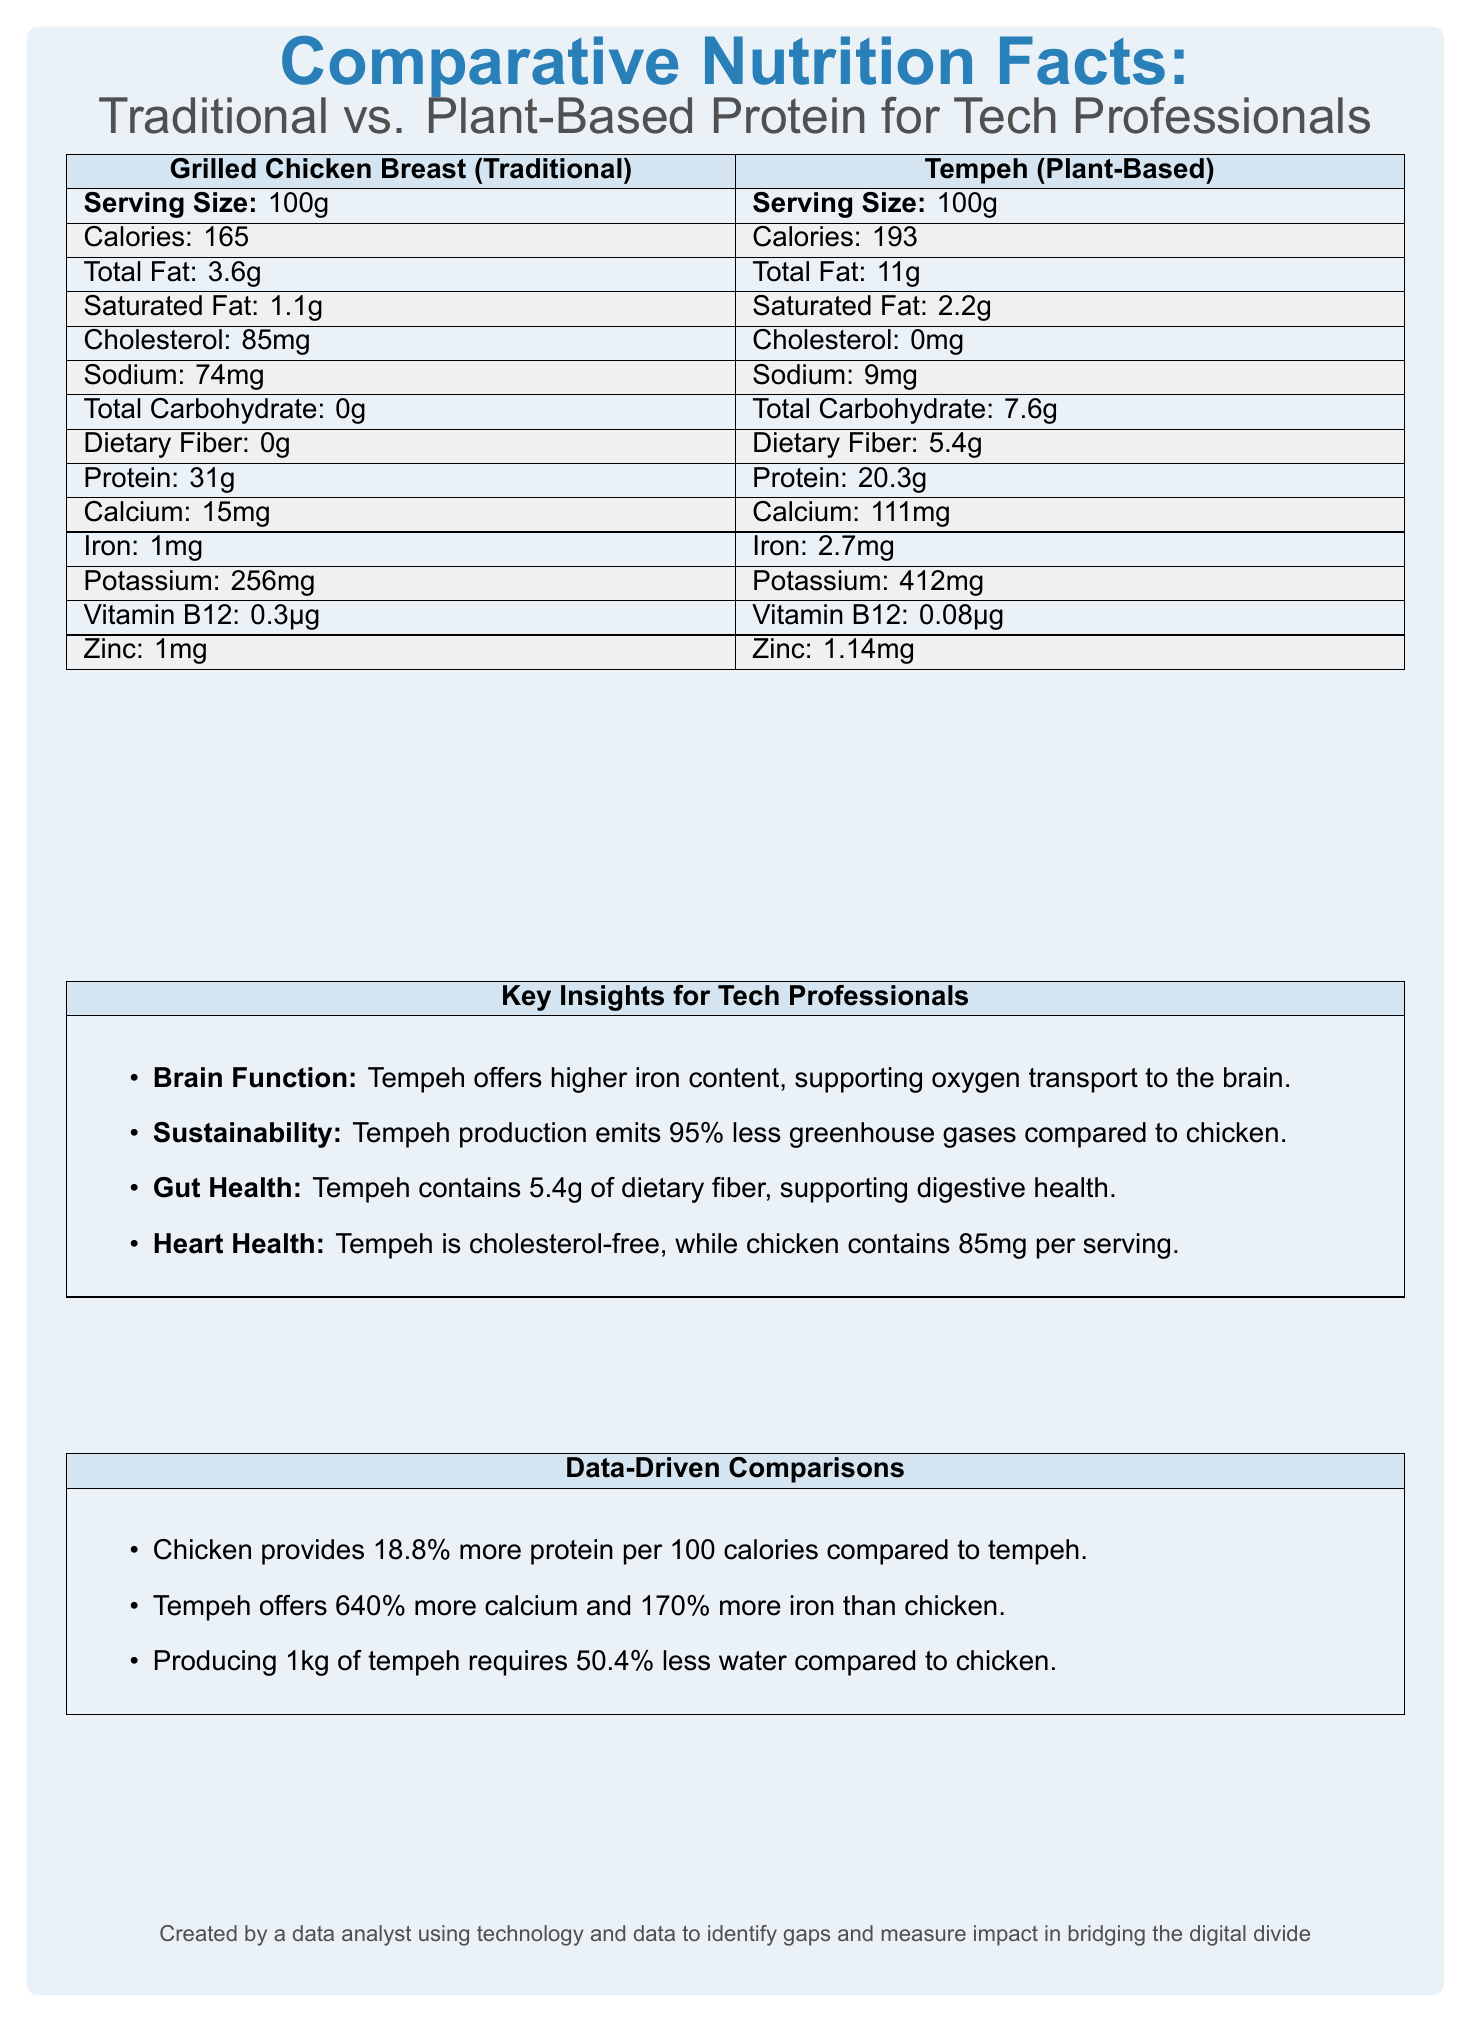what is the serving size for both protein sources? The serving size is stated as 100g for both Grilled Chicken Breast (Traditional) and Tempeh (Plant-Based).
Answer: 100g how much dietary fiber does tempeh contain? The document indicates that Tempeh has 5.4g of dietary fiber per serving.
Answer: 5.4g how much protein does grilled chicken breast provide? The Grilled Chicken Breast provides 31g of protein per serving according to the document.
Answer: 31g which nutrient does tempeh offer more of compared to chicken in terms of milligrams or micrograms? Tempeh offers significantly more calcium and iron than chicken (Calcium: 111mg vs. 15mg, Iron: 2.7mg vs. 1mg).
Answer: calcium and iron is tempeh a cholesterol-free option? The document states that Tempeh contains 0mg of cholesterol, making it a cholesterol-free option.
Answer: Yes which food option has a higher total fat content? A. Grilled Chicken Breast B. Tempeh C. Both have the same Tempeh has a higher total fat content of 11g compared to Grilled Chicken Breast which has 3.6g.
Answer: B which food option provides more vitamin B12? 1. Grilled Chicken Breast 2. Tempeh 3. Both have the same Grilled Chicken Breast provides 0.3µg of vitamin B12, while Tempeh provides 0.08µg.
Answer: 1 does tempeh align with sustainability goals in the tech industry? The document mentions that Tempeh production emits 95% less greenhouse gases compared to chicken, aligning with sustainability goals.
Answer: Yes what is one key insight related to heart health for tech professionals? The document highlights that Tempeh is cholesterol-free, which is notable for heart health concerns prevalent among tech professionals.
Answer: Tempeh is cholesterol-free. which protein source offers better support for cognitive function? The document states that Tempeh offers higher iron content, which supports oxygen transport to the brain, crucial for cognitive function.
Answer: Tempeh how many more liters of water are saved when producing 1kg of tempeh compared to 1kg of chicken? The document mentions that producing 1kg of tempeh requires about 2,145 liters of water, compared to 4,325 liters for chicken, saving approximately 2,180 liters.
Answer: Approximately 2,180 liters could producing tempeh mitigate water usage concerns in the tech industry? The document supports this with the data showing that tempeh production requires 50.4% less water compared to chicken.
Answer: Yes what percentage more protein per 100 calories does chicken provide compared to tempeh? The document states that chicken provides 18.8% more protein per 100 calories compared to tempeh.
Answer: 18.8% summarize the main purpose of the document. The document provides a detailed comparison to guide tech professionals in choosing between traditional and plant-based protein sources, focusing on nutritional values, cognitive support, sustainability, gut health, and heart health concerns.
Answer: The document compares the nutritional facts and sustainability insights of traditional grilled chicken breast and plant-based tempeh to help tech professionals make informed dietary choices. It highlights their differences in terms of macronutrients, micronutrients, environmental impact, and specific health benefits. what is the total sugar content for tempeh? The document lists the total sugar content of Tempeh as 0.8g per serving.
Answer: 0.8g which protein source is better for digestive health and why? The document indicates that Tempeh contains 5.4g of dietary fiber, supporting digestive health, unlike chicken, which has no dietary fiber.
Answer: Tempeh can the document's insights be applied to all professional industries? The document specifically addresses tech professionals, emphasizing cognitive function, sedentary lifestyle impacts, and sustainability goals relevant to the tech industry.
Answer: Not entirely how many servings per container are there for both protein sources? The document states that there is 1 serving per container for both Grilled Chicken Breast and Tempeh.
Answer: 1 what is tempeh's benefit related to nerve function in tech professionals? The document states chicken provides more vitamin B12 for nerve function but does not detail tempeh's specific benefit related to nerve function.
Answer: Cannot be determined 